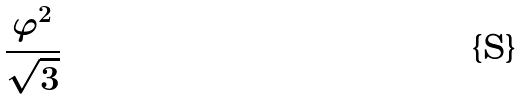<formula> <loc_0><loc_0><loc_500><loc_500>\frac { \varphi ^ { 2 } } { \sqrt { 3 } }</formula> 